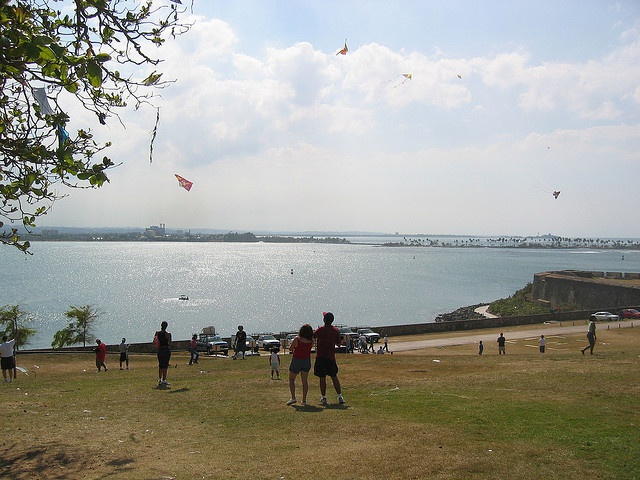Describe the objects in this image and their specific colors. I can see people in black, olive, gray, and darkgray tones, people in black, gray, olive, and darkgray tones, people in black, maroon, and gray tones, people in black, gray, and maroon tones, and kite in black, lightgray, brown, darkgray, and gray tones in this image. 